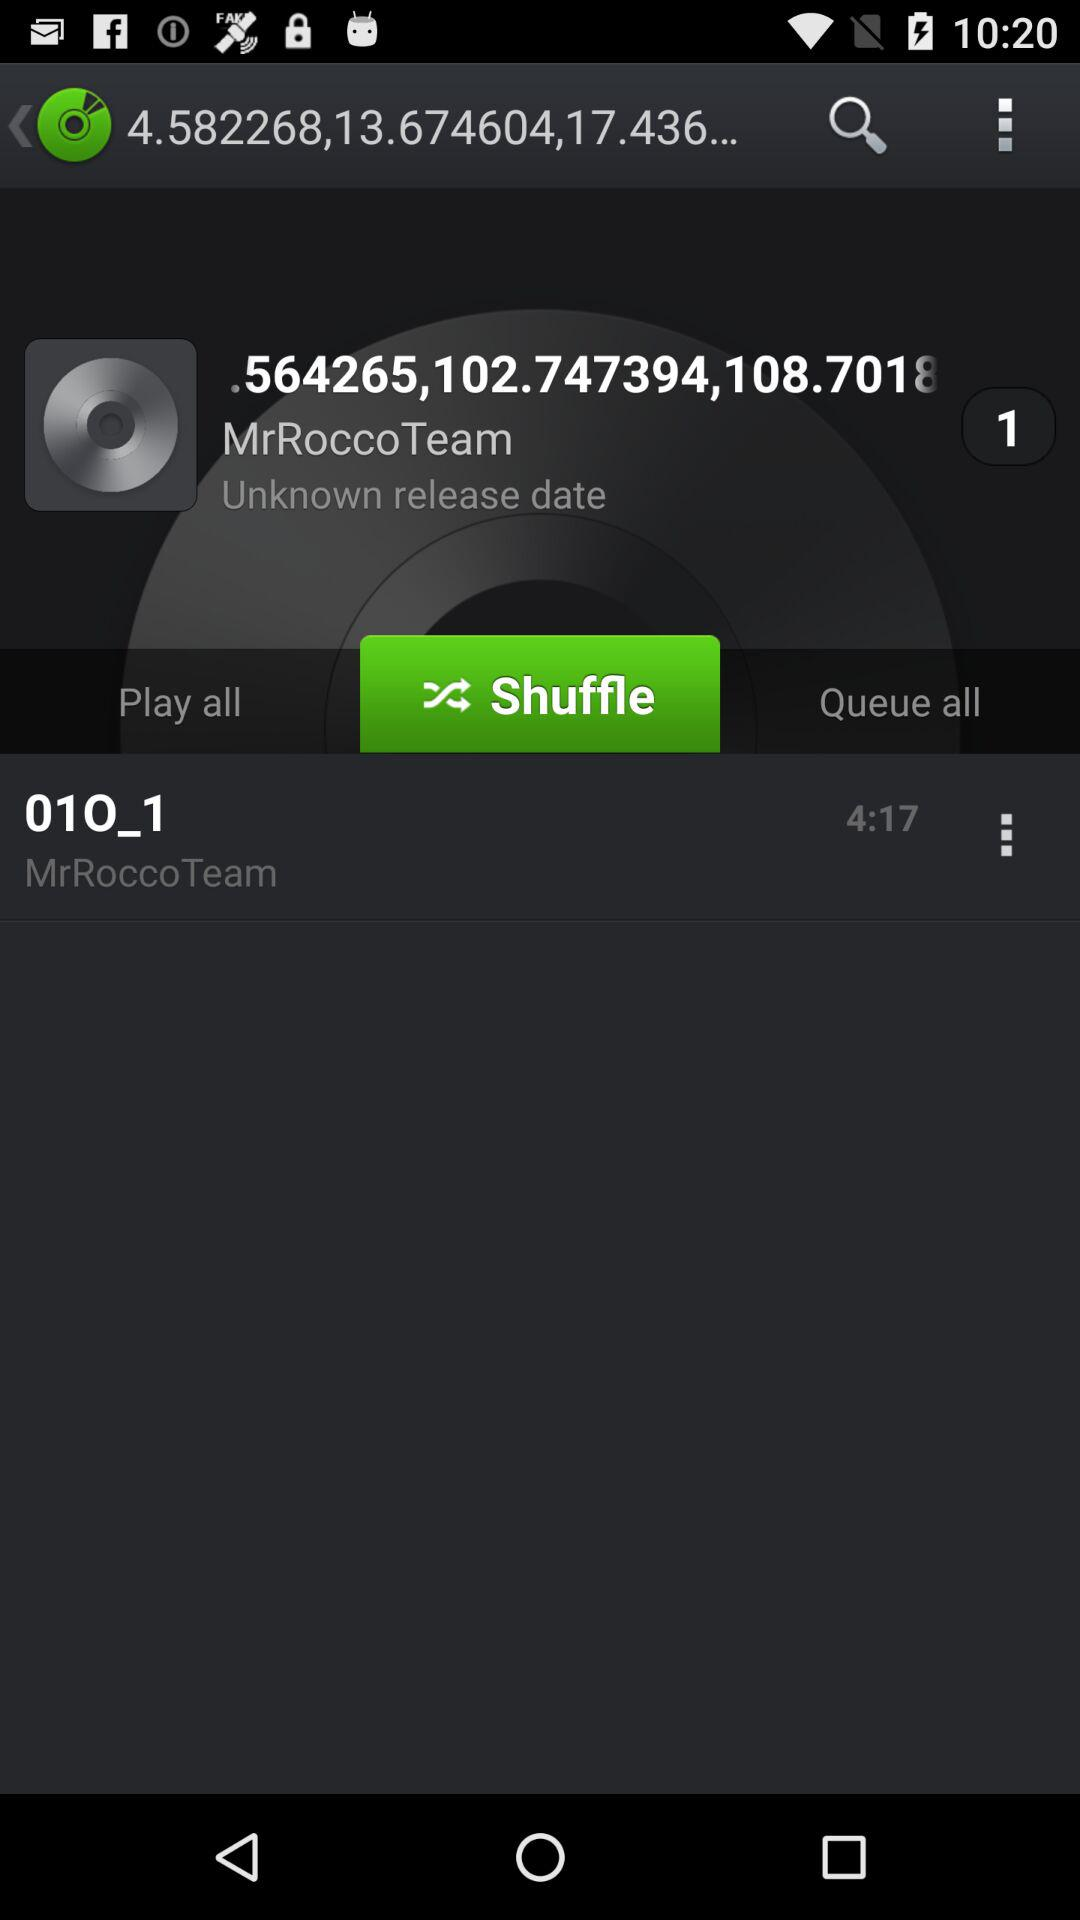Which audio is playing? The audio playing is.564265,102.747394,108.7018. 